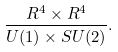<formula> <loc_0><loc_0><loc_500><loc_500>\frac { { R } ^ { 4 } \times { R } ^ { 4 } } { U ( 1 ) \times S U ( 2 ) } .</formula> 